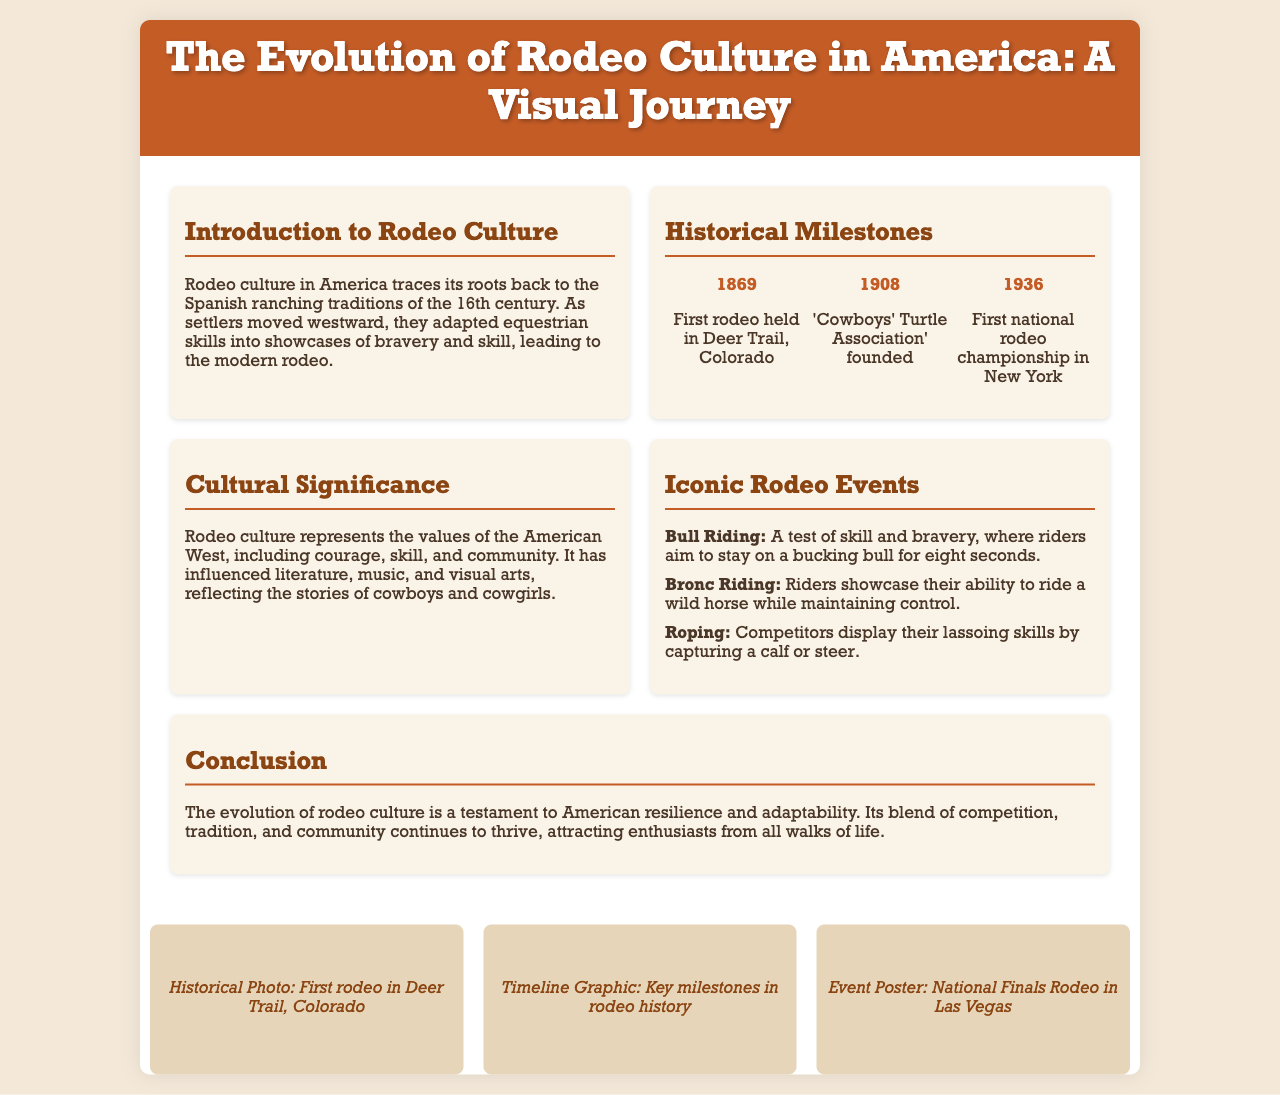what year was the first rodeo held? The document states that the first rodeo was held in Deer Trail, Colorado in 1869.
Answer: 1869 what organization was founded in 1908? The document mentions the founding of the 'Cowboys' Turtle Association' in 1908.
Answer: Cowboys' Turtle Association what cultural values does rodeo culture represent? According to the document, rodeo culture represents courage, skill, and community.
Answer: courage, skill, and community how long do riders aim to stay on a bucking bull in bull riding? The document specifies that riders aim to stay on a bucking bull for eight seconds.
Answer: eight seconds what was the first national rodeo championship location? The document indicates that the first national rodeo championship took place in New York.
Answer: New York who are reflected in the stories associated with rodeo culture? The document states that the stories of cowboys and cowgirls are reflected in rodeo culture.
Answer: cowboys and cowgirls what is the main theme of the conclusion section? The conclusion discusses the evolution of rodeo culture as a testament to American resilience and adaptability.
Answer: resilience and adaptability what type of visuals are included in the brochure? The brochure includes historical photos, timeline graphics, and event posters as visual elements.
Answer: historical photos, timeline graphics, event posters 